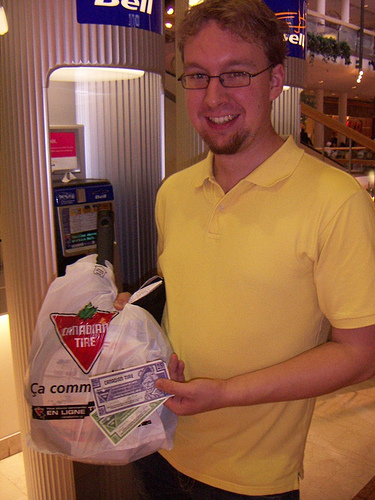<image>
Is there a man in front of the carry bag? No. The man is not in front of the carry bag. The spatial positioning shows a different relationship between these objects. 